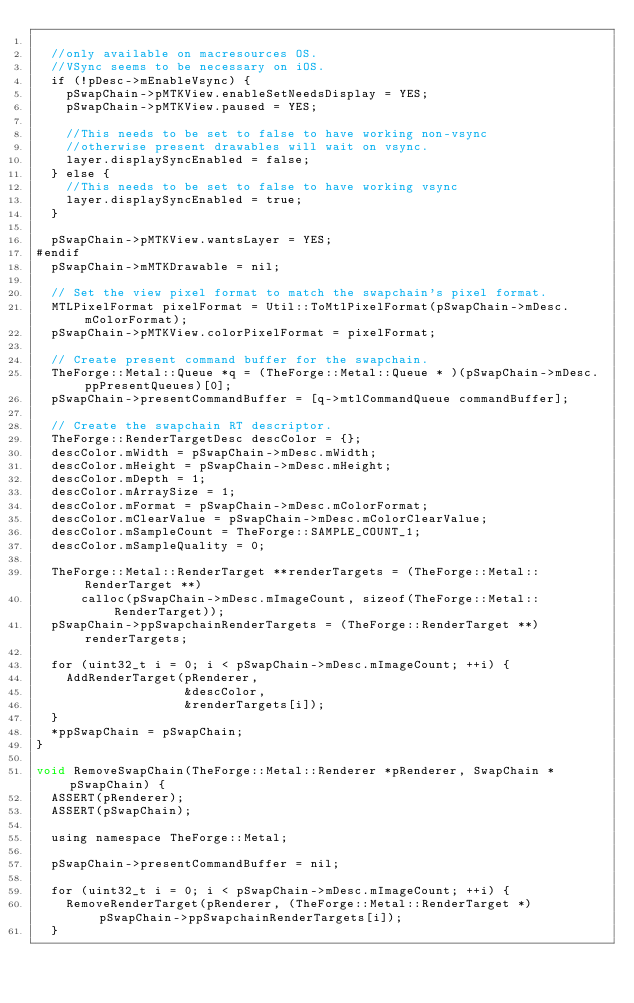Convert code to text. <code><loc_0><loc_0><loc_500><loc_500><_ObjectiveC_>
  //only available on macresources OS.
  //VSync seems to be necessary on iOS.
  if (!pDesc->mEnableVsync) {
    pSwapChain->pMTKView.enableSetNeedsDisplay = YES;
    pSwapChain->pMTKView.paused = YES;

    //This needs to be set to false to have working non-vsync
    //otherwise present drawables will wait on vsync.
    layer.displaySyncEnabled = false;
  } else {
    //This needs to be set to false to have working vsync
    layer.displaySyncEnabled = true;
  }

  pSwapChain->pMTKView.wantsLayer = YES;
#endif
  pSwapChain->mMTKDrawable = nil;

  // Set the view pixel format to match the swapchain's pixel format.
  MTLPixelFormat pixelFormat = Util::ToMtlPixelFormat(pSwapChain->mDesc.mColorFormat);
  pSwapChain->pMTKView.colorPixelFormat = pixelFormat;

  // Create present command buffer for the swapchain.
  TheForge::Metal::Queue *q = (TheForge::Metal::Queue * )(pSwapChain->mDesc.ppPresentQueues)[0];
  pSwapChain->presentCommandBuffer = [q->mtlCommandQueue commandBuffer];

  // Create the swapchain RT descriptor.
  TheForge::RenderTargetDesc descColor = {};
  descColor.mWidth = pSwapChain->mDesc.mWidth;
  descColor.mHeight = pSwapChain->mDesc.mHeight;
  descColor.mDepth = 1;
  descColor.mArraySize = 1;
  descColor.mFormat = pSwapChain->mDesc.mColorFormat;
  descColor.mClearValue = pSwapChain->mDesc.mColorClearValue;
  descColor.mSampleCount = TheForge::SAMPLE_COUNT_1;
  descColor.mSampleQuality = 0;

  TheForge::Metal::RenderTarget **renderTargets = (TheForge::Metal::RenderTarget **)
      calloc(pSwapChain->mDesc.mImageCount, sizeof(TheForge::Metal::RenderTarget));
  pSwapChain->ppSwapchainRenderTargets = (TheForge::RenderTarget **) renderTargets;

  for (uint32_t i = 0; i < pSwapChain->mDesc.mImageCount; ++i) {
    AddRenderTarget(pRenderer,
                    &descColor,
                    &renderTargets[i]);
  }
  *ppSwapChain = pSwapChain;
}

void RemoveSwapChain(TheForge::Metal::Renderer *pRenderer, SwapChain *pSwapChain) {
  ASSERT(pRenderer);
  ASSERT(pSwapChain);

  using namespace TheForge::Metal;

  pSwapChain->presentCommandBuffer = nil;

  for (uint32_t i = 0; i < pSwapChain->mDesc.mImageCount; ++i) {
    RemoveRenderTarget(pRenderer, (TheForge::Metal::RenderTarget *) pSwapChain->ppSwapchainRenderTargets[i]);
  }
</code> 